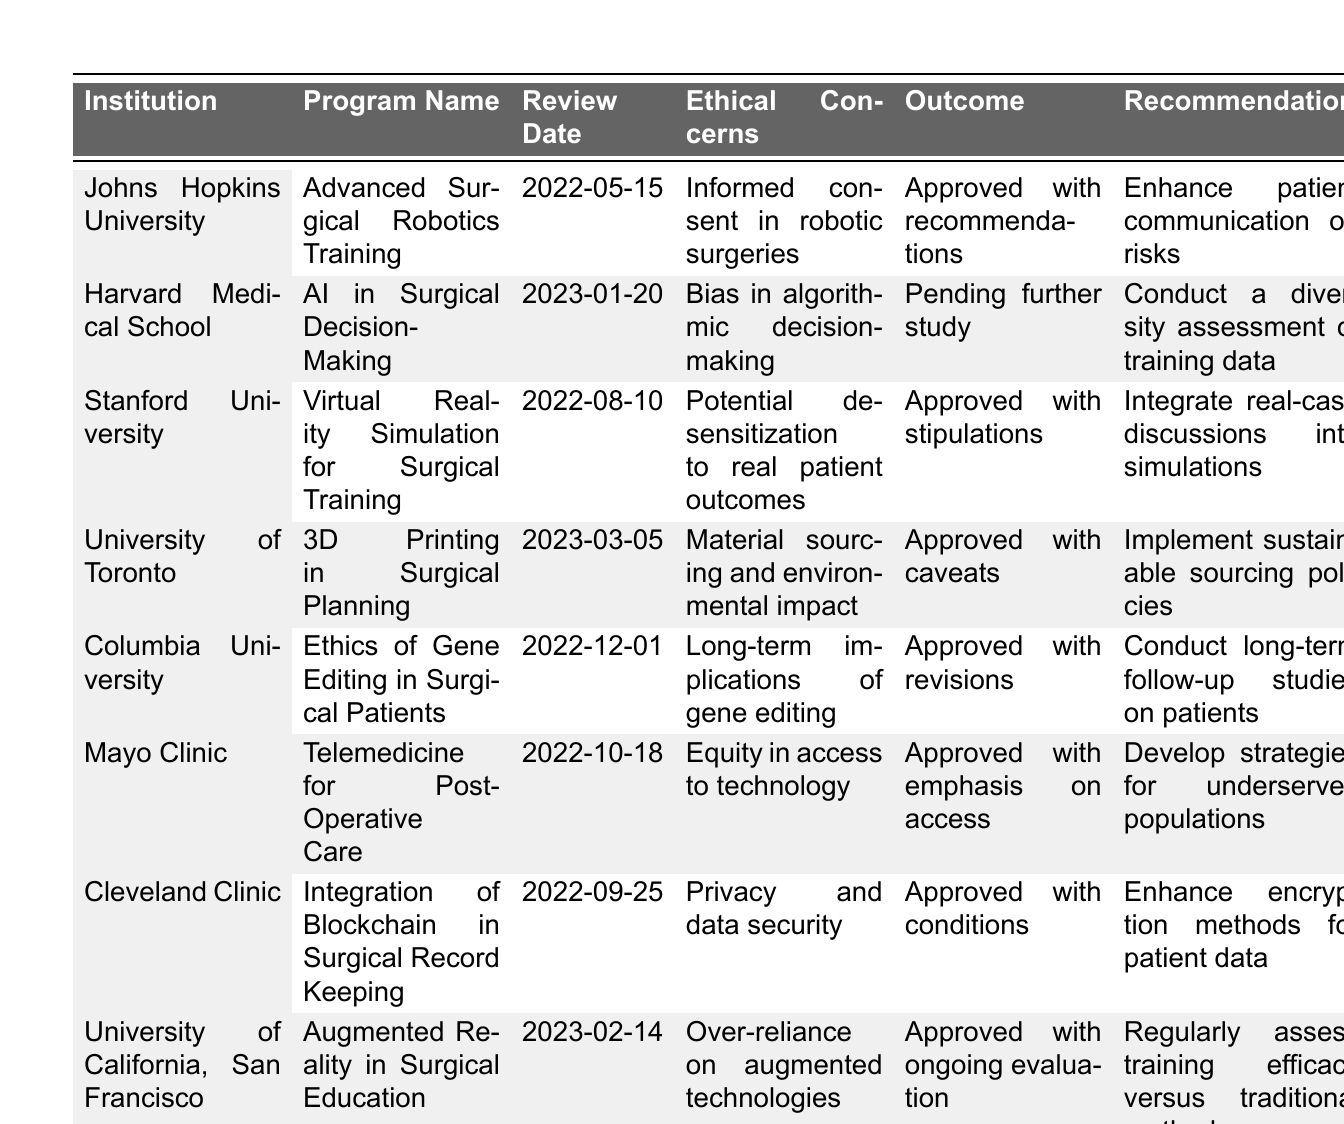What is the outcome of the review for Johns Hopkins University's program? The table lists "Approved with recommendations" as the outcome for the "Advanced Surgical Robotics Training" program at Johns Hopkins University.
Answer: Approved with recommendations How many programs addressed ethical concerns related to access to technology? From the table, only one program, Mayo Clinic's "Telemedicine for Post-Operative Care," specifically addresses equity in access to technology.
Answer: One Which institution had their program outcome pending further study? The table shows that Harvard Medical School's program "AI in Surgical Decision-Making" has an outcome of "Pending further study."
Answer: Harvard Medical School What was the recommendation for the University of Toronto's program? The table states that the recommendation for the "3D Printing in Surgical Planning" program is to "Implement sustainable sourcing policies."
Answer: Implement sustainable sourcing policies Is there a program that received an approval with specific conditions mentioned? Yes, the "Integration of Blockchain in Surgical Record Keeping" program from Cleveland Clinic received an "Approved with conditions" outcome.
Answer: Yes Which program had ethical concerns related to algorithmic decision-making? The "AI in Surgical Decision-Making" program from Harvard Medical School specifically addresses bias in algorithmic decision-making as an ethical concern.
Answer: AI in Surgical Decision-Making Count how many programs were approved with recommendations versus those pending further study. The table lists one program with an outcome of pending study (Harvard Medical School) and four programs showing various approval outcomes (such as approved with recommendations or conditions). Therefore, 4 were approved, and 1 was pending.
Answer: 4 approved, 1 pending What recommendations were given for the program addressing privacy and data security concerns? The table specifies that for the program "Integration of Blockchain in Surgical Record Keeping," the recommendation is to "Enhance encryption methods for patient data."
Answer: Enhance encryption methods for patient data Evaluate the overall focus of ethical concerns across all programs. The table reveals diverse concerns such as consent, algorithm bias, patient desensitization, sustainability, gene editing implications, access equity, data privacy, and technology reliance, indicating a wide range of ethical focus areas.
Answer: Diverse ethical concerns Which program had ethical implications associated with long-term effects, and what was the recommendation? The "Ethics of Gene Editing in Surgical Patients" program at Columbia University had concerns about long-term implications of gene editing, with a recommendation to "Conduct long-term follow-up studies on patients."
Answer: Conduct long-term follow-up studies on patients 